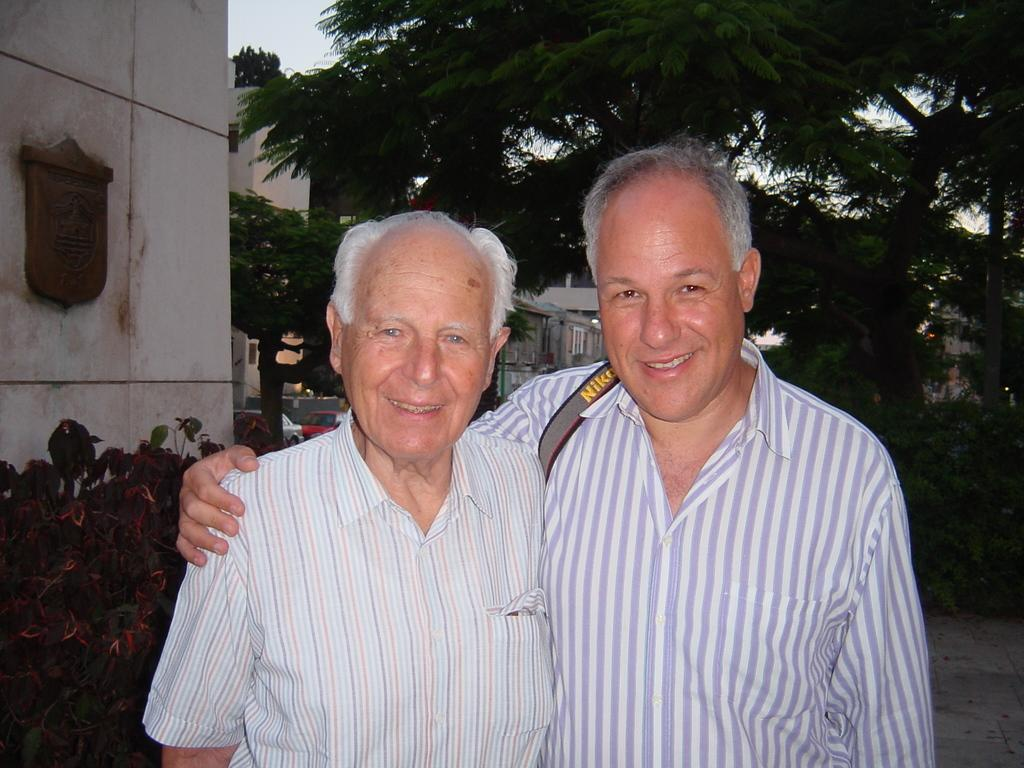<image>
Create a compact narrative representing the image presented. two men hugging and one has a strap that says Nikon on it 